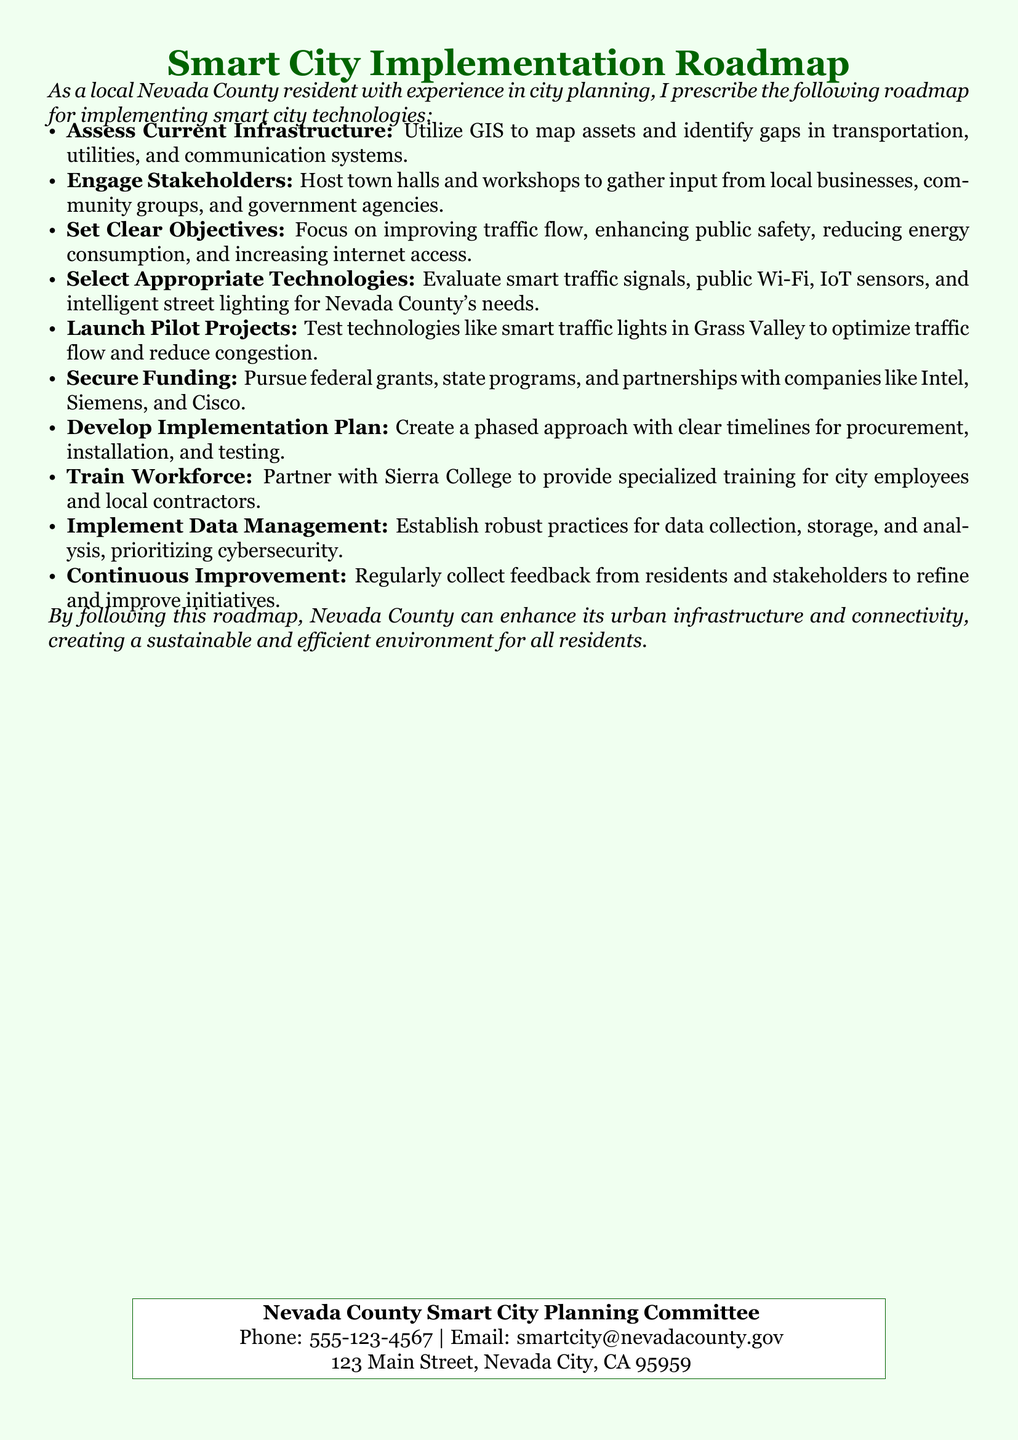What is the title of the document? The title of the document is stated prominently at the top of the page.
Answer: Smart City Implementation Roadmap Who is responsible for the smart city planning in Nevada County? The document mentions the committee that oversees the planning efforts.
Answer: Nevada County Smart City Planning Committee What technological area is focused on in the roadmap? The roadmap emphasizes specific technologies to address urban challenges.
Answer: Smart city technologies What is the first step outlined in the roadmap? The first step is crucial for understanding the current challenges faced by the community.
Answer: Assess Current Infrastructure What local institution is mentioned for workforce training? This institution is identified as a partner for training city employees and contractors.
Answer: Sierra College How can funding be secured for the smart city initiatives? The document suggests various methods to obtain financial resources for the implementation.
Answer: Federal grants What is the purpose of launching pilot projects? The pilot projects aim to evaluate the effectiveness of selected technologies.
Answer: Optimize traffic flow What should be established according to the roadmap for managing data? This aspect is vital for ensuring data security and effective use of information.
Answer: Robust practices What approach is recommended for implementing the technologies? This aspect guides the efforts in a structured and timely manner.
Answer: Phased approach 